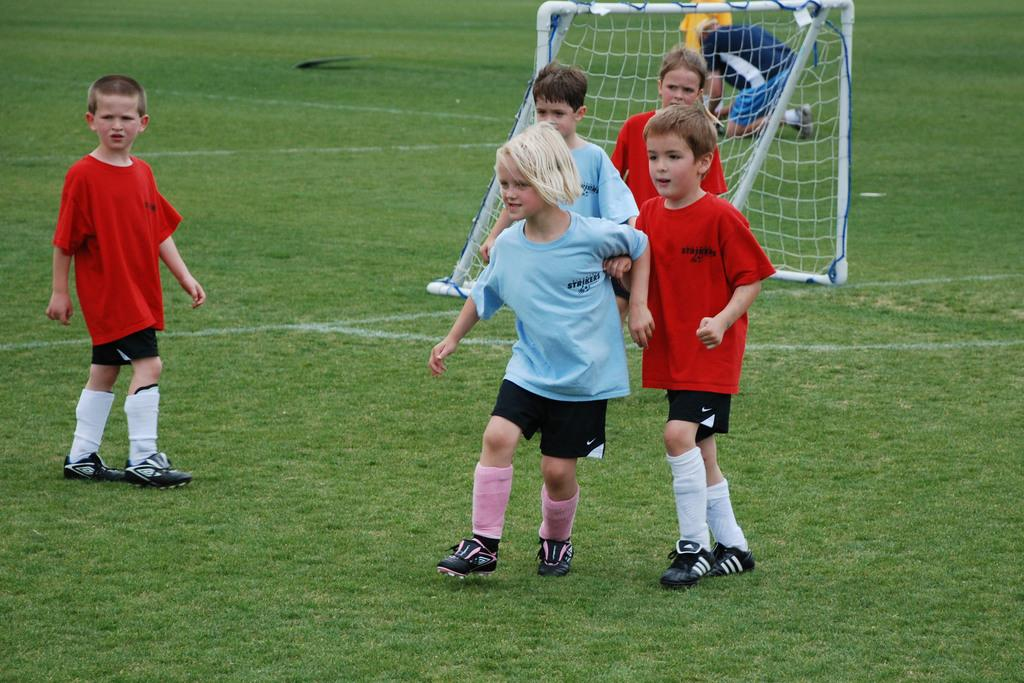What are the people in the image doing? The people in the image are standing. Is there anyone in the image performing a different action? Yes, there is a person kneeling in the image. What can be seen in the background of the image? There is a football goal post in the image. Where is the football goal post located? The football goal post is on the grass. What type of thread is being used to smash the cherries in the image? There are no cherries or thread present in the image. How many cherries can be seen being smashed by the thread in the image? There are no cherries or thread present in the image, so it is not possible to answer this question. 